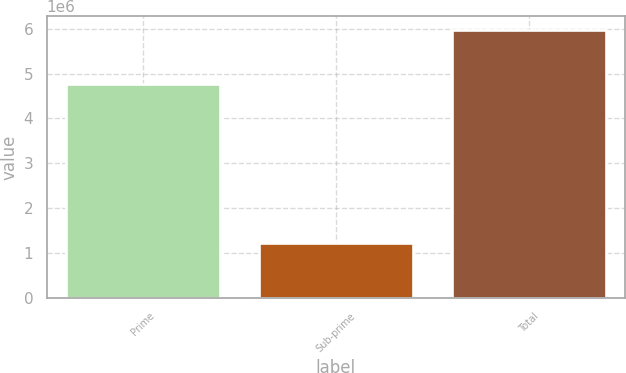Convert chart. <chart><loc_0><loc_0><loc_500><loc_500><bar_chart><fcel>Prime<fcel>Sub-prime<fcel>Total<nl><fcel>4.76842e+06<fcel>1.21379e+06<fcel>5.98221e+06<nl></chart> 